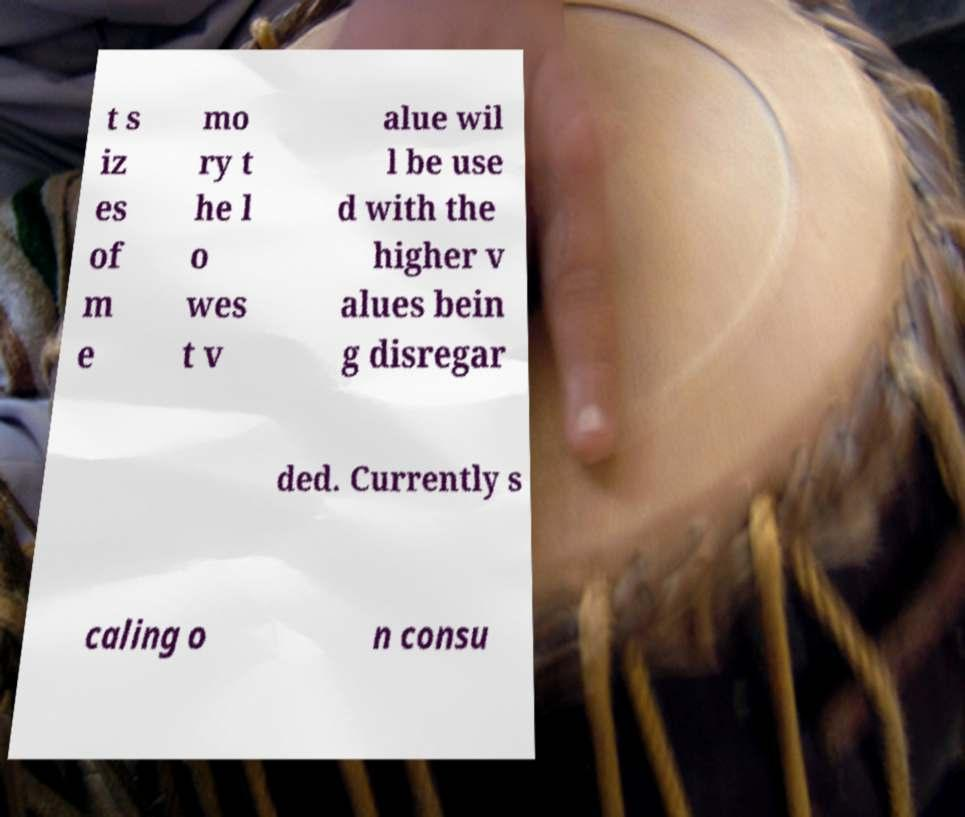There's text embedded in this image that I need extracted. Can you transcribe it verbatim? t s iz es of m e mo ry t he l o wes t v alue wil l be use d with the higher v alues bein g disregar ded. Currently s caling o n consu 